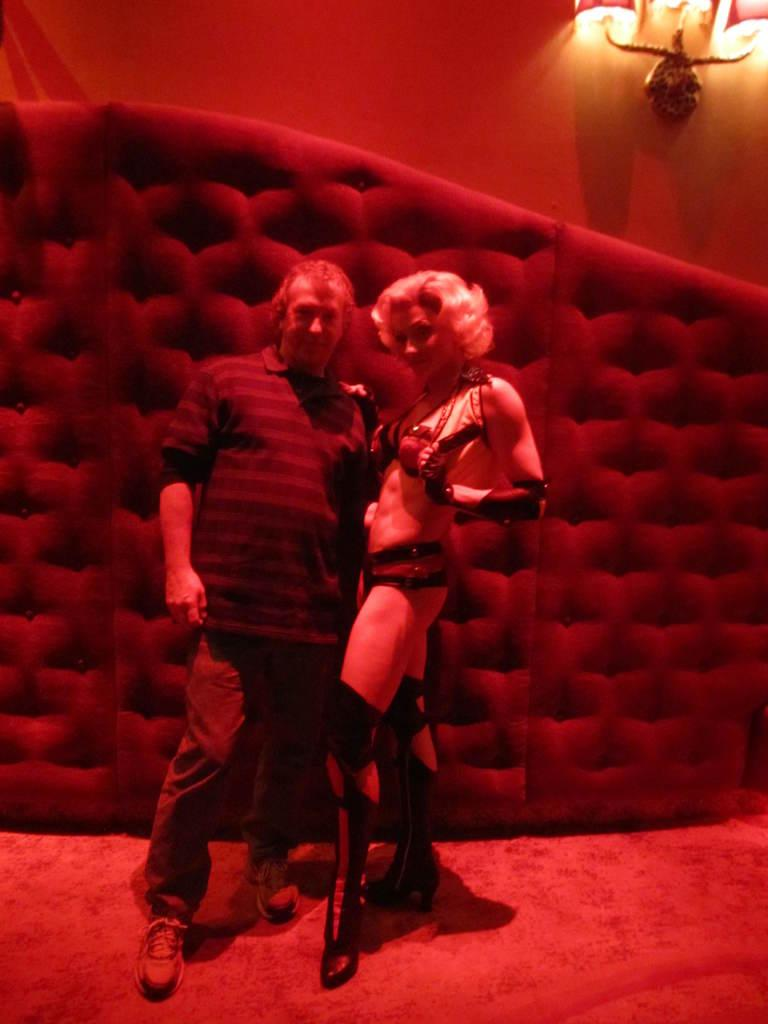Who are the people in the image? There is a man and a woman in the image. What are the positions of the man and woman in the image? Both the man and woman are standing on the floor. What can be seen in the background of the image? There is a wall and lights visible in the background of the image. What type of unit is the man pulling in the image? There is no unit present in the image, nor is the man pulling anything. 